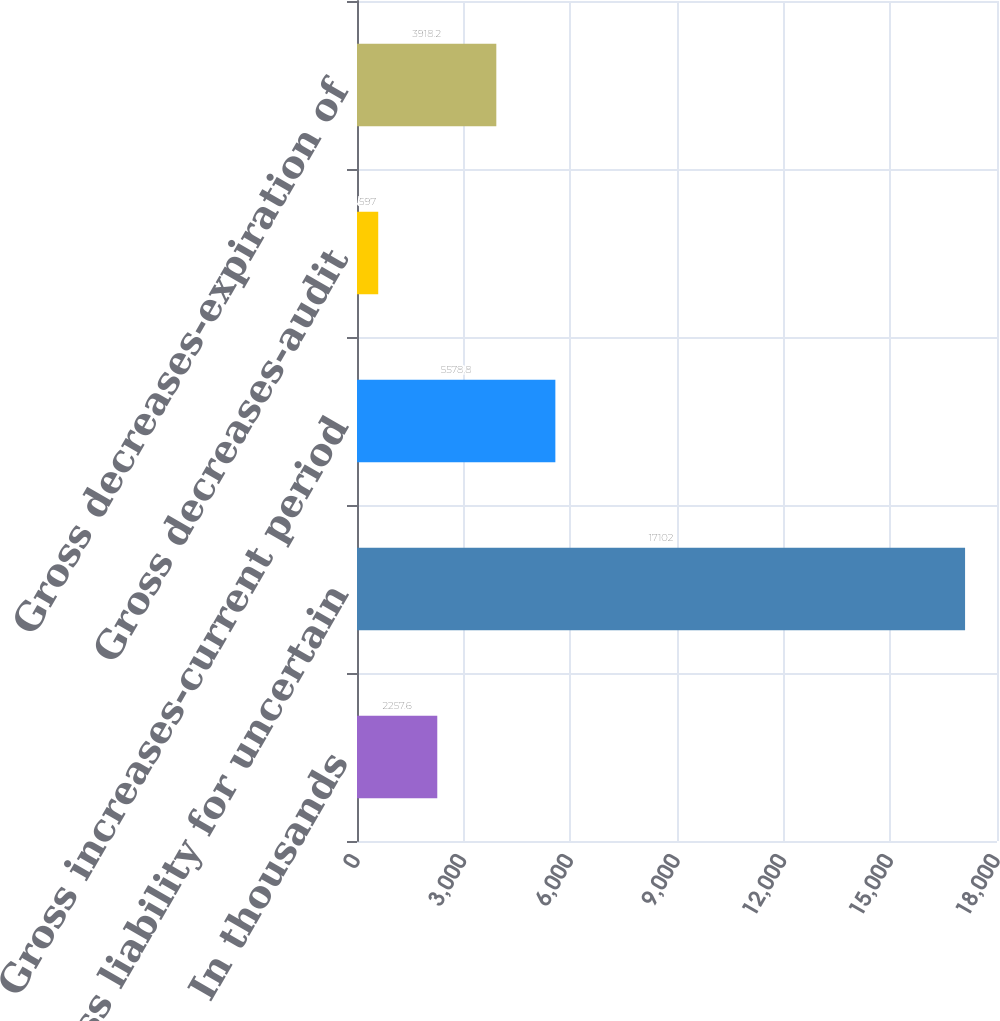Convert chart to OTSL. <chart><loc_0><loc_0><loc_500><loc_500><bar_chart><fcel>In thousands<fcel>Gross liability for uncertain<fcel>Gross increases-current period<fcel>Gross decreases-audit<fcel>Gross decreases-expiration of<nl><fcel>2257.6<fcel>17102<fcel>5578.8<fcel>597<fcel>3918.2<nl></chart> 